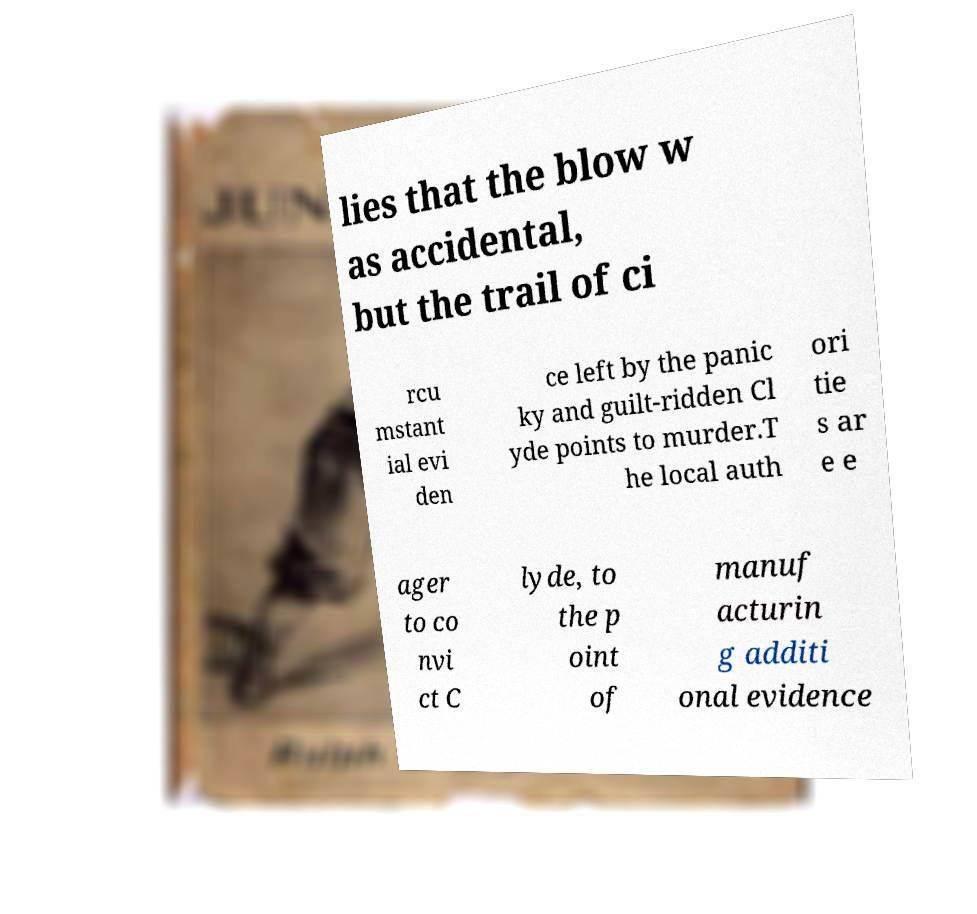Please identify and transcribe the text found in this image. lies that the blow w as accidental, but the trail of ci rcu mstant ial evi den ce left by the panic ky and guilt-ridden Cl yde points to murder.T he local auth ori tie s ar e e ager to co nvi ct C lyde, to the p oint of manuf acturin g additi onal evidence 